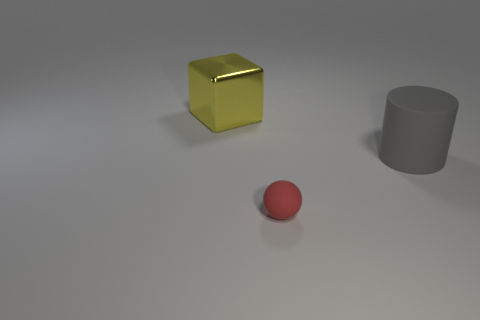Can you describe the lighting of the scene? The scene is lit from above with a soft light, as indicated by the gentle shadows cast underneath the objects. The light source creates a subtle highlight on the upper surfaces of the objects, particularly noticeable on the reflective yellow cube. 